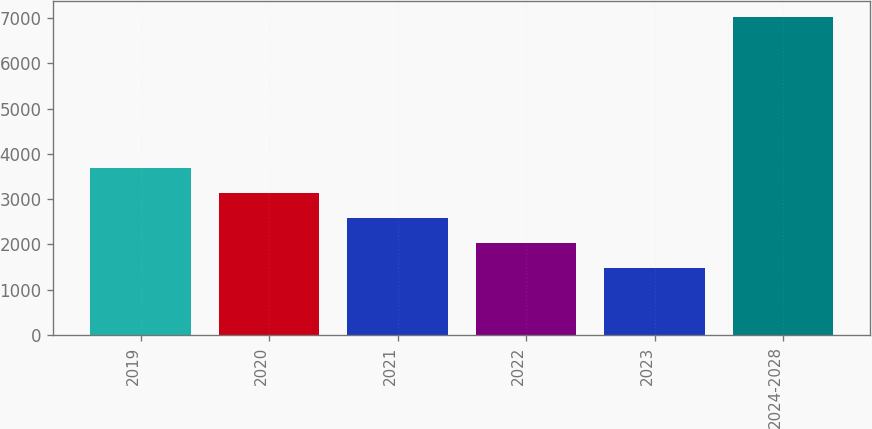Convert chart to OTSL. <chart><loc_0><loc_0><loc_500><loc_500><bar_chart><fcel>2019<fcel>2020<fcel>2021<fcel>2022<fcel>2023<fcel>2024-2028<nl><fcel>3695.6<fcel>3139.7<fcel>2583.8<fcel>2027.9<fcel>1472<fcel>7031<nl></chart> 